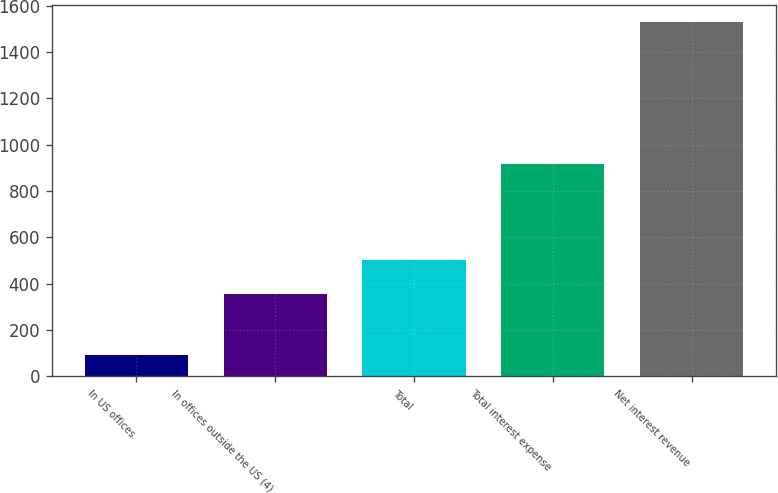<chart> <loc_0><loc_0><loc_500><loc_500><bar_chart><fcel>In US offices<fcel>In offices outside the US (4)<fcel>Total<fcel>Total interest expense<fcel>Net interest revenue<nl><fcel>91<fcel>358<fcel>501.7<fcel>918<fcel>1528<nl></chart> 